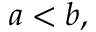<formula> <loc_0><loc_0><loc_500><loc_500>a < b ,</formula> 